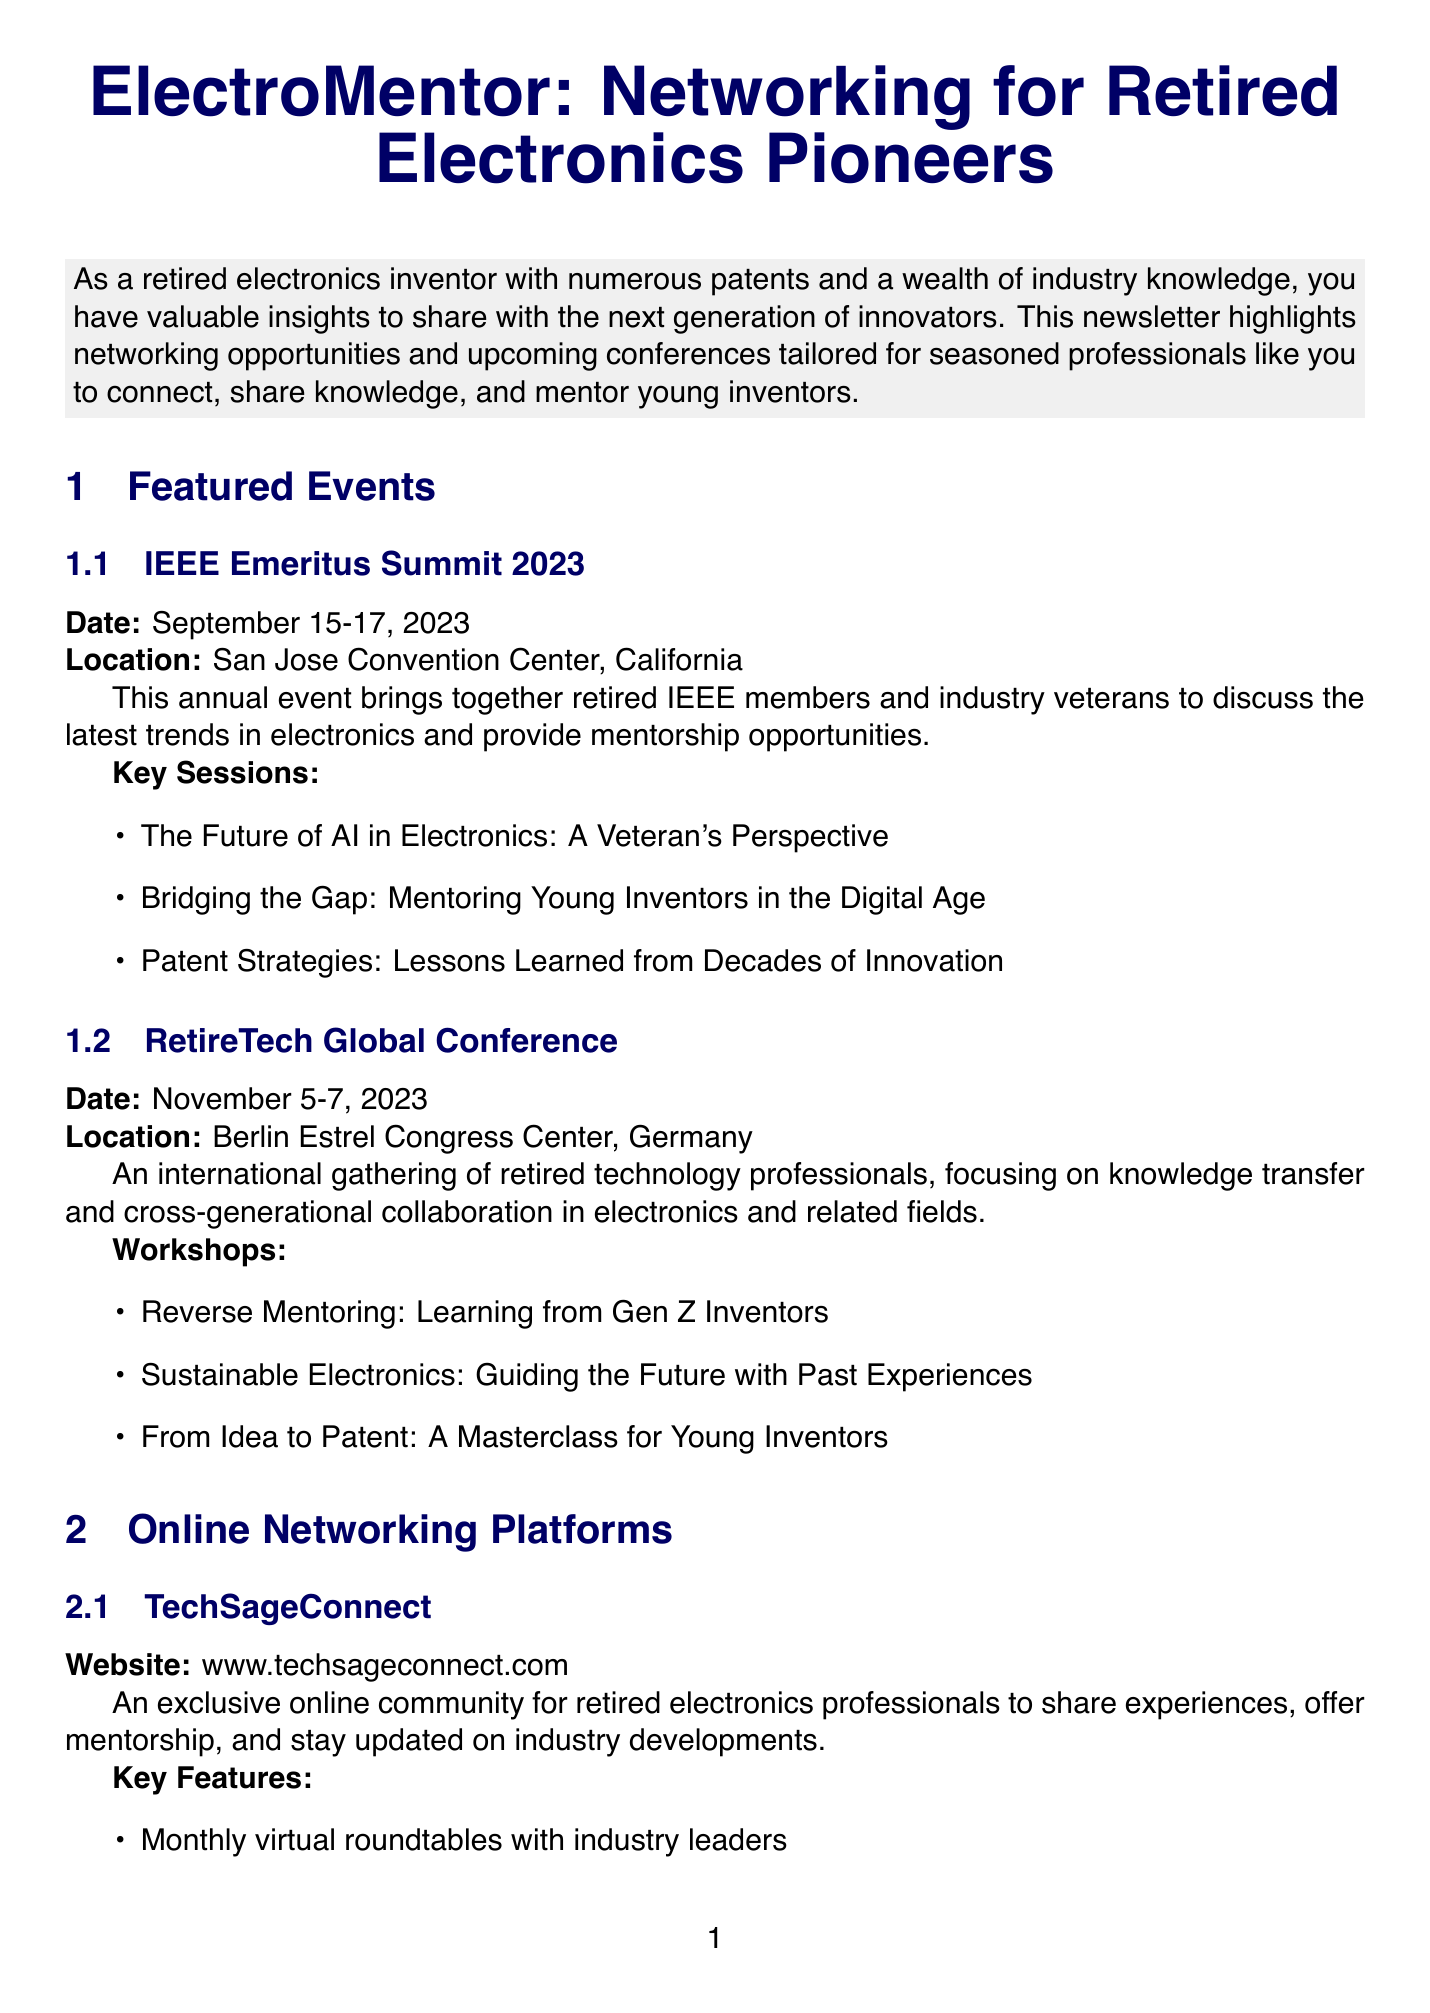What is the title of the newsletter? The title of the newsletter is stated at the beginning of the document.
Answer: ElectroMentor: Networking for Retired Electronics Pioneers When is the IEEE Emeritus Summit 2023? The date for the event is clearly mentioned in the featured events section.
Answer: September 15-17, 2023 Where will the RetireTech Global Conference take place? The location of the conference is provided in its description.
Answer: Berlin Estrel Congress Center, Germany What organization runs the NextGen Inventors Program? The organizer of the program is specified in the mentorship programs section.
Answer: National Inventors Hall of Fame How often does the Silicon Valley Electronics Pioneers group meet? The meeting frequency for this local meetup group is explicitly stated.
Answer: Monthly What commitment is required for the Women in Electronics Mentorship Initiative? The commitment length of the program is detailed in the description of the mentorship programs.
Answer: 1-year program What key feature does TechSageConnect offer? A key feature of this online networking platform is highlighted in its description.
Answer: Monthly virtual roundtables with industry leaders What type of event is the upcoming event for the Tokyo Denshi Meiyo Kai? The nature of the event is indicated in the description of the local meetup groups.
Answer: Annual Electronics Innovation Award ceremony for university students 